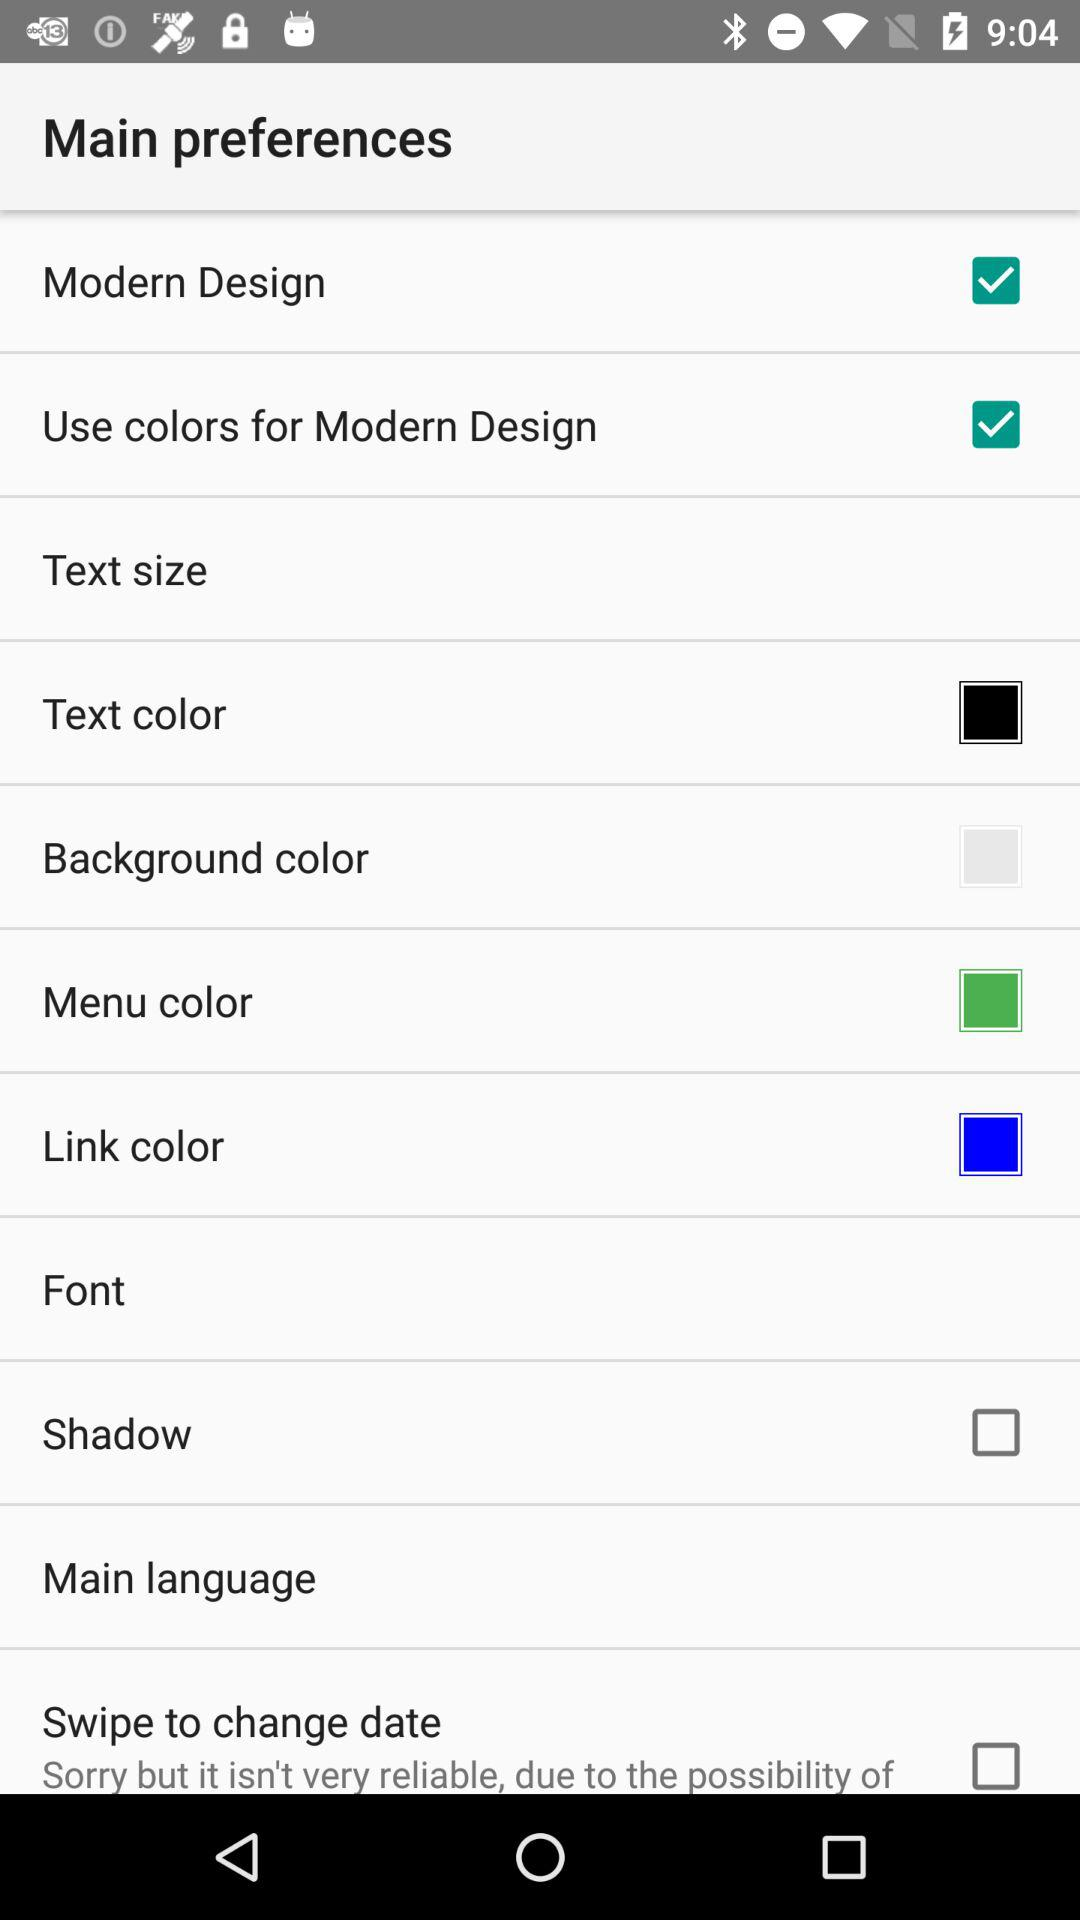What is the text color? The text color is black. 